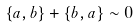<formula> <loc_0><loc_0><loc_500><loc_500>\{ a , b \} + \{ b , a \} \sim 0</formula> 